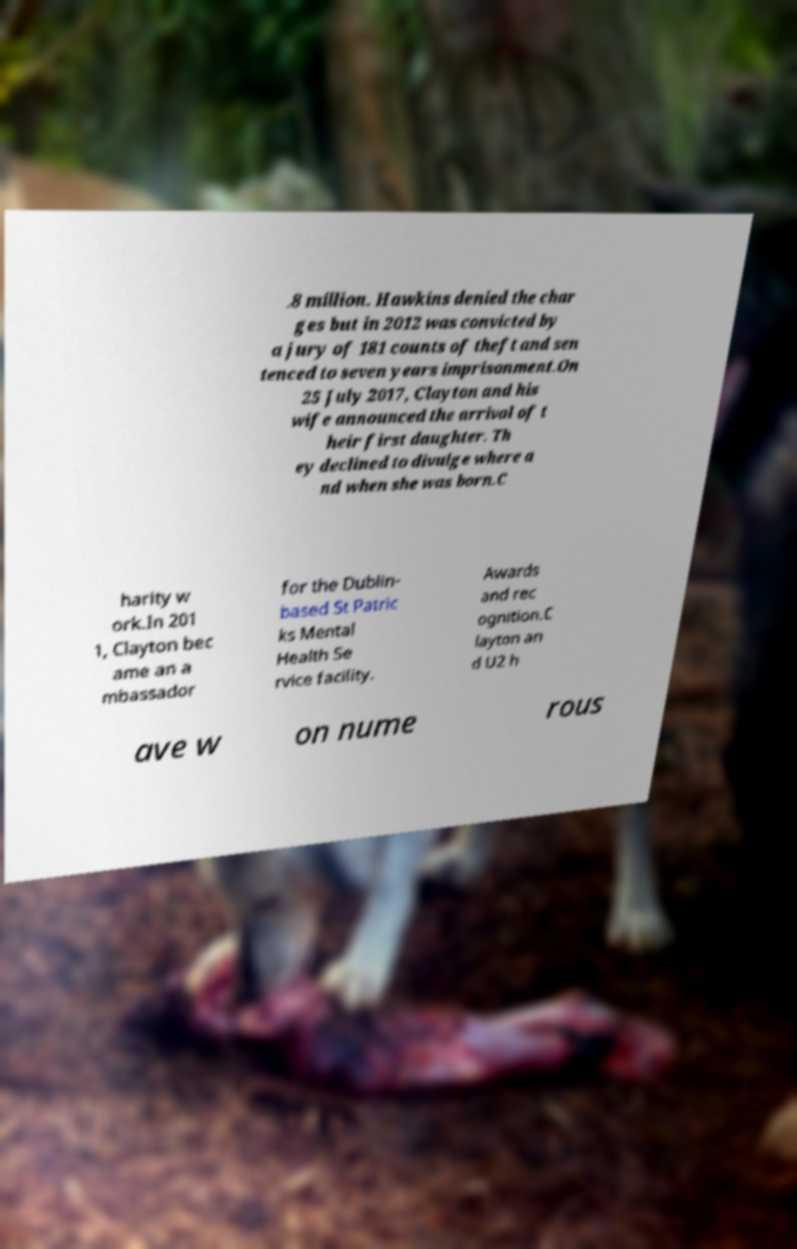Please identify and transcribe the text found in this image. .8 million. Hawkins denied the char ges but in 2012 was convicted by a jury of 181 counts of theft and sen tenced to seven years imprisonment.On 25 July 2017, Clayton and his wife announced the arrival of t heir first daughter. Th ey declined to divulge where a nd when she was born.C harity w ork.In 201 1, Clayton bec ame an a mbassador for the Dublin- based St Patric ks Mental Health Se rvice facility. Awards and rec ognition.C layton an d U2 h ave w on nume rous 